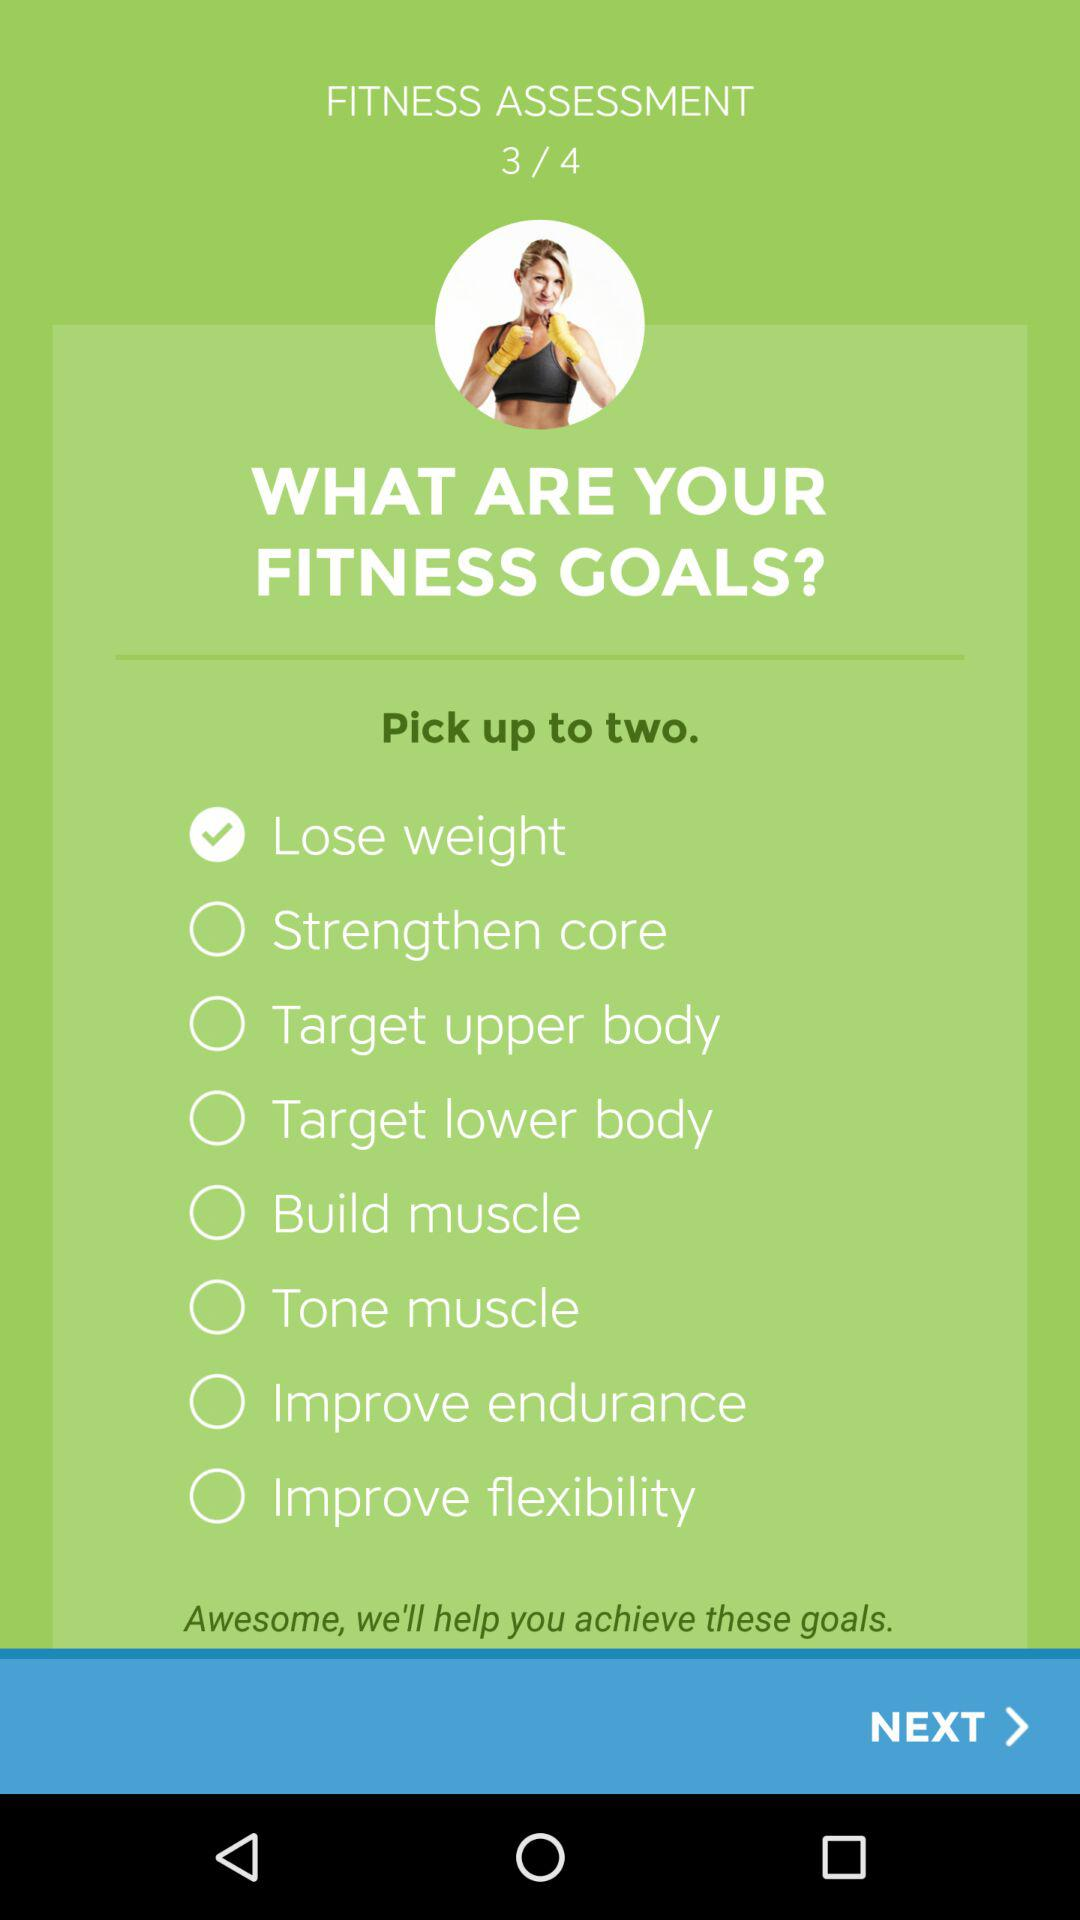How many sets are there in the "FITNESS ASSESSMENT"? There are 4 sets. 